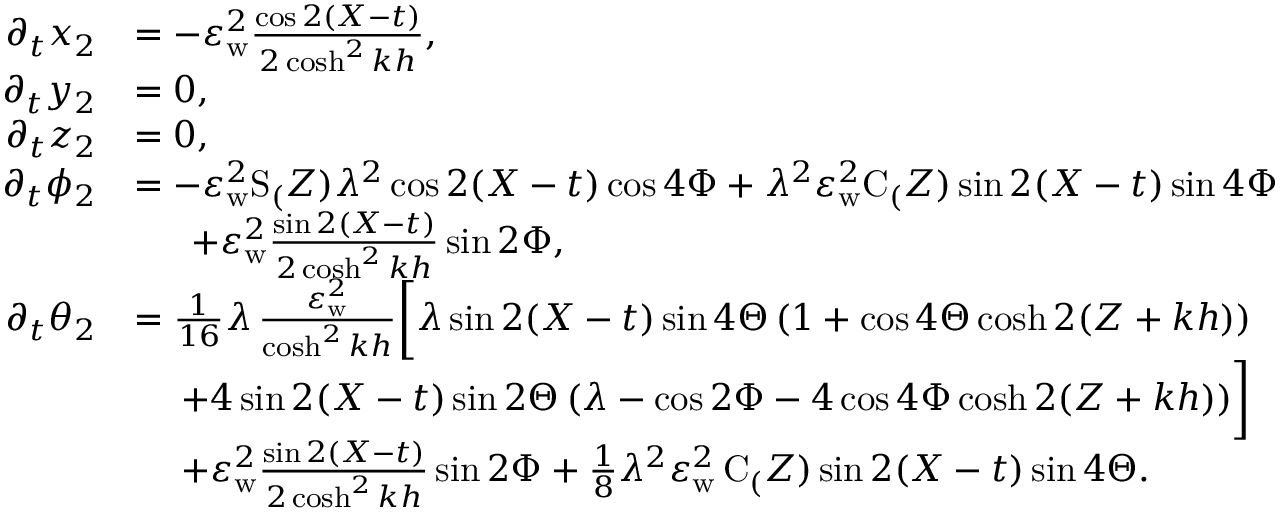Convert formula to latex. <formula><loc_0><loc_0><loc_500><loc_500>\begin{array} { r l } { \partial _ { t } x _ { 2 } } & { = - \varepsilon _ { w } ^ { 2 } \frac { \cos 2 ( X - t ) } { 2 \cosh ^ { 2 } k h } , } \\ { \partial _ { t } y _ { 2 } } & { = 0 , } \\ { \partial _ { t } z _ { 2 } } & { = 0 , } \\ { \partial _ { t } { \phi _ { 2 } } } & { = - \varepsilon _ { w } ^ { 2 } S _ { ( } Z ) \lambda ^ { 2 } \cos 2 ( X - t ) \cos { 4 \Phi } + \lambda ^ { 2 } \varepsilon _ { w } ^ { 2 } C _ { ( } Z ) \sin 2 ( X - t ) \sin { 4 \Phi } } \\ & { \quad \, + \varepsilon _ { w } ^ { 2 } \frac { \sin 2 ( X - t ) } { 2 \cosh ^ { 2 } k h } \sin { 2 \Phi } , } \\ { \partial _ { t } { \theta _ { 2 } } } & { = \frac { 1 } { 1 6 } \lambda \, \frac { \varepsilon _ { w } ^ { 2 } } { \cosh ^ { 2 } k h } \left [ \lambda \sin 2 ( X - t ) \sin { 4 \Theta } \, ( 1 + \cos { 4 \Theta } \cosh 2 ( Z + k h ) ) } \\ & { \quad \, + 4 \sin 2 ( X - t ) \sin { 2 \Theta } \, ( \lambda - \cos { 2 \Phi } - 4 \cos { 4 \Phi } \cosh 2 ( Z + k h ) ) \right ] } \\ & { \quad \, + \varepsilon _ { w } ^ { 2 } \frac { \sin 2 ( X - t ) } { 2 \cosh ^ { 2 } k h } \sin { 2 \Phi } + \frac { 1 } { 8 } \lambda ^ { 2 } \varepsilon _ { w } ^ { 2 } \, C _ { ( } Z ) \sin 2 ( X - t ) \sin { 4 \Theta } . } \end{array}</formula> 